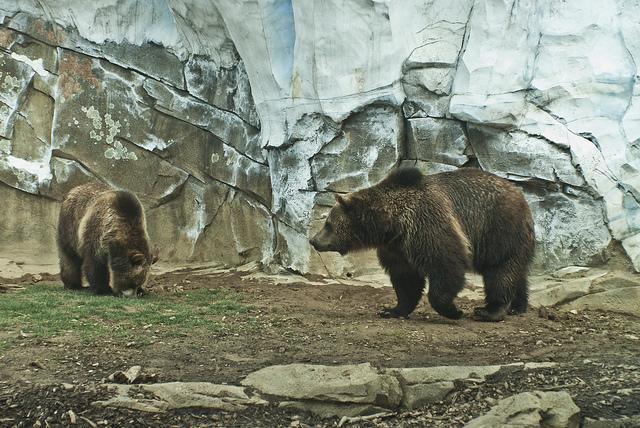Is the ground rocks or dirt?
Quick response, please. Dirt. Is the bear in its natural habitat?
Give a very brief answer. No. How many animals are there?
Quick response, please. 2. What are the bears doing?
Short answer required. Walking. What color are the bears?
Give a very brief answer. Brown. Is the bear eating?
Keep it brief. Yes. Are these cubs?
Short answer required. No. What color are these bears?
Be succinct. Brown. How many bears are there?
Short answer required. 2. Are these bears black?
Concise answer only. No. Which animal is bigger?
Be succinct. Bear on right. The bear on the right has how many feet touching the ground?
Give a very brief answer. 3. 